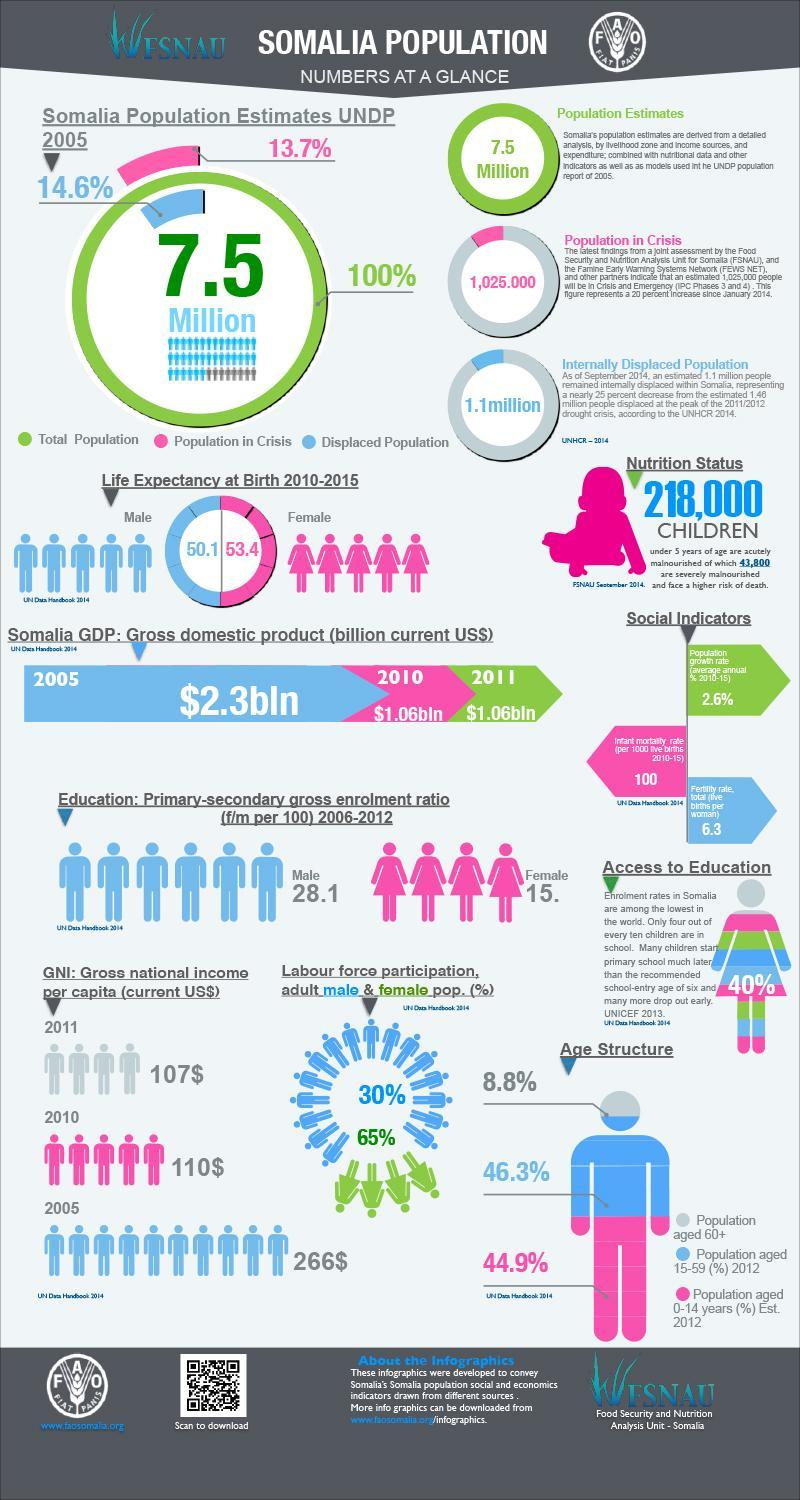What is the GDP value (in billion current US$) of Somalia in 2010?
Answer the question with a short phrase. $1.06bln What is the life expectancy of male at birth in Somalia during 2010-2015? 50.1 What percent of the Somalia population is aged between 15-59 years in 2012? 46.3% What percent of the Somalia population is aged above 60 years in 2012? 8.8% What is the primary-secondary gross enrolment ratio of male (per 100) in Somalia during 2006-2012? 28.1 What is the life expectancy of female at birth in Somalia during 2010-2015? 53.4 What percent is the adult male population in the Somalia labor force? 30% What is the GNI per capita (in current US$) of Somalia in 2005? 266$ What percentage of the Somalia Population is in Crisis according to the UNDP in 2005? 13.7% What is the female labor force participation rate in Somalia? 65% 